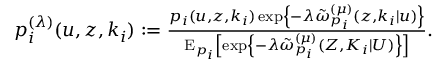Convert formula to latex. <formula><loc_0><loc_0><loc_500><loc_500>\begin{array} { r l } & { p _ { i } ^ { ( \lambda ) } ( u , { z } , k _ { i } ) \colon = \frac { p _ { i } ( u , { z } , k _ { i } ) \exp \left \{ - \lambda \tilde { \omega } _ { p _ { i } } ^ { ( \mu ) } ( z , k _ { i } | u ) \right \} } { E _ { p _ { i } } \left [ \exp \left \{ - \lambda \tilde { \omega } _ { p _ { i } } ^ { ( \mu ) } ( { Z } , K _ { i } | U ) \right \} \right ] } . } \end{array}</formula> 